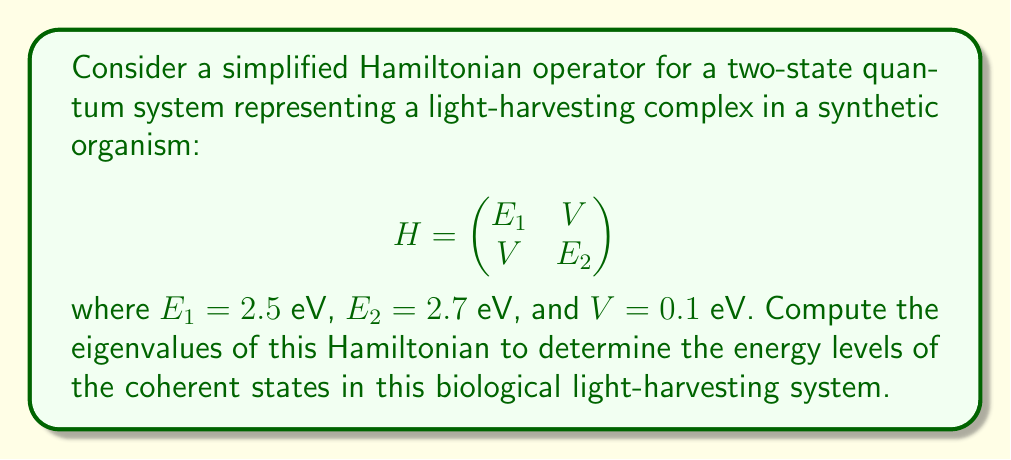Teach me how to tackle this problem. To find the eigenvalues of the given Hamiltonian, we need to solve the characteristic equation:

1) First, we set up the characteristic equation:
   $$\det(H - \lambda I) = 0$$

2) Expanding this determinant:
   $$\begin{vmatrix}
   2.5 - \lambda & 0.1 \\
   0.1 & 2.7 - \lambda
   \end{vmatrix} = 0$$

3) Calculating the determinant:
   $$(2.5 - \lambda)(2.7 - \lambda) - (0.1)(0.1) = 0$$

4) Expanding the equation:
   $$\lambda^2 - 5.2\lambda + 6.74 = 0$$

5) This is a quadratic equation in the form $a\lambda^2 + b\lambda + c = 0$,
   where $a=1$, $b=-5.2$, and $c=6.74$

6) We can solve this using the quadratic formula:
   $$\lambda = \frac{-b \pm \sqrt{b^2 - 4ac}}{2a}$$

7) Substituting our values:
   $$\lambda = \frac{5.2 \pm \sqrt{5.2^2 - 4(1)(6.74)}}{2(1)}$$

8) Simplifying:
   $$\lambda = \frac{5.2 \pm \sqrt{27.04 - 26.96}}{2} = \frac{5.2 \pm \sqrt{0.08}}{2}$$

9) Calculating the final values:
   $$\lambda_1 = \frac{5.2 + \sqrt{0.08}}{2} \approx 2.6141 \text{ eV}$$
   $$\lambda_2 = \frac{5.2 - \sqrt{0.08}}{2} \approx 2.5859 \text{ eV}$$

These eigenvalues represent the energy levels of the coherent states in the biological light-harvesting system.
Answer: $\lambda_1 \approx 2.6141 \text{ eV}$, $\lambda_2 \approx 2.5859 \text{ eV}$ 